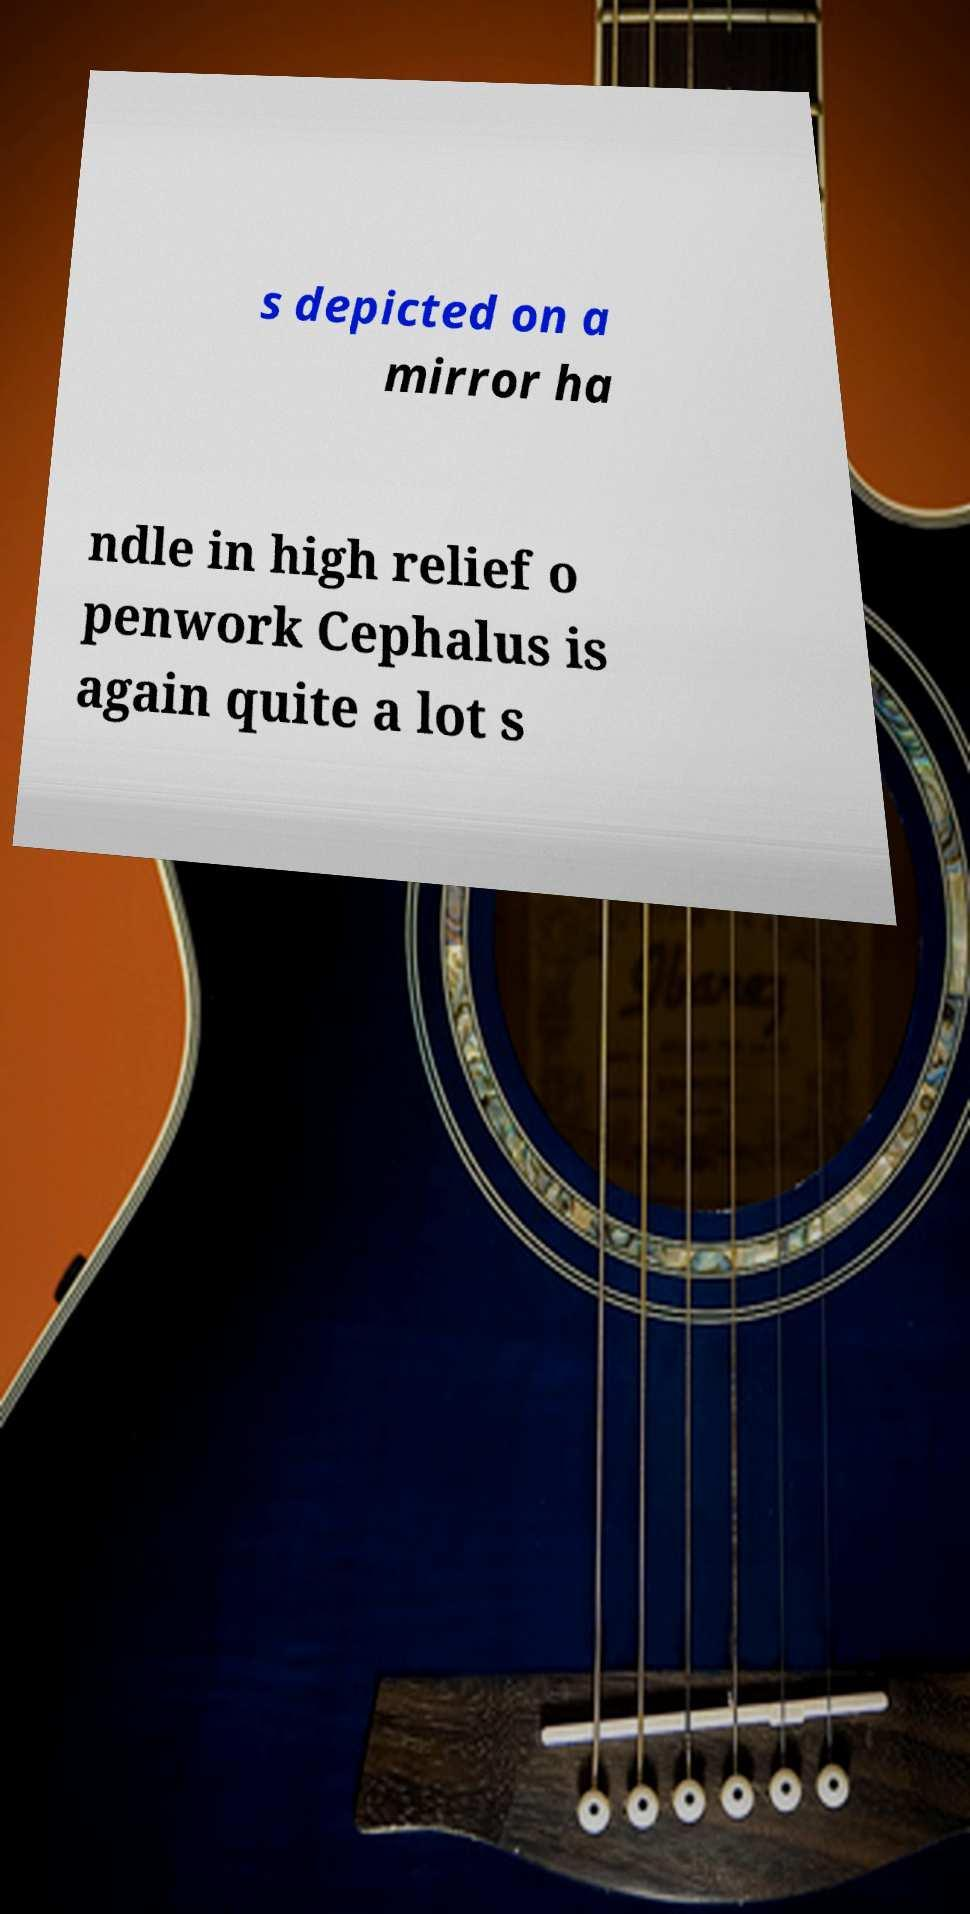Please read and relay the text visible in this image. What does it say? s depicted on a mirror ha ndle in high relief o penwork Cephalus is again quite a lot s 